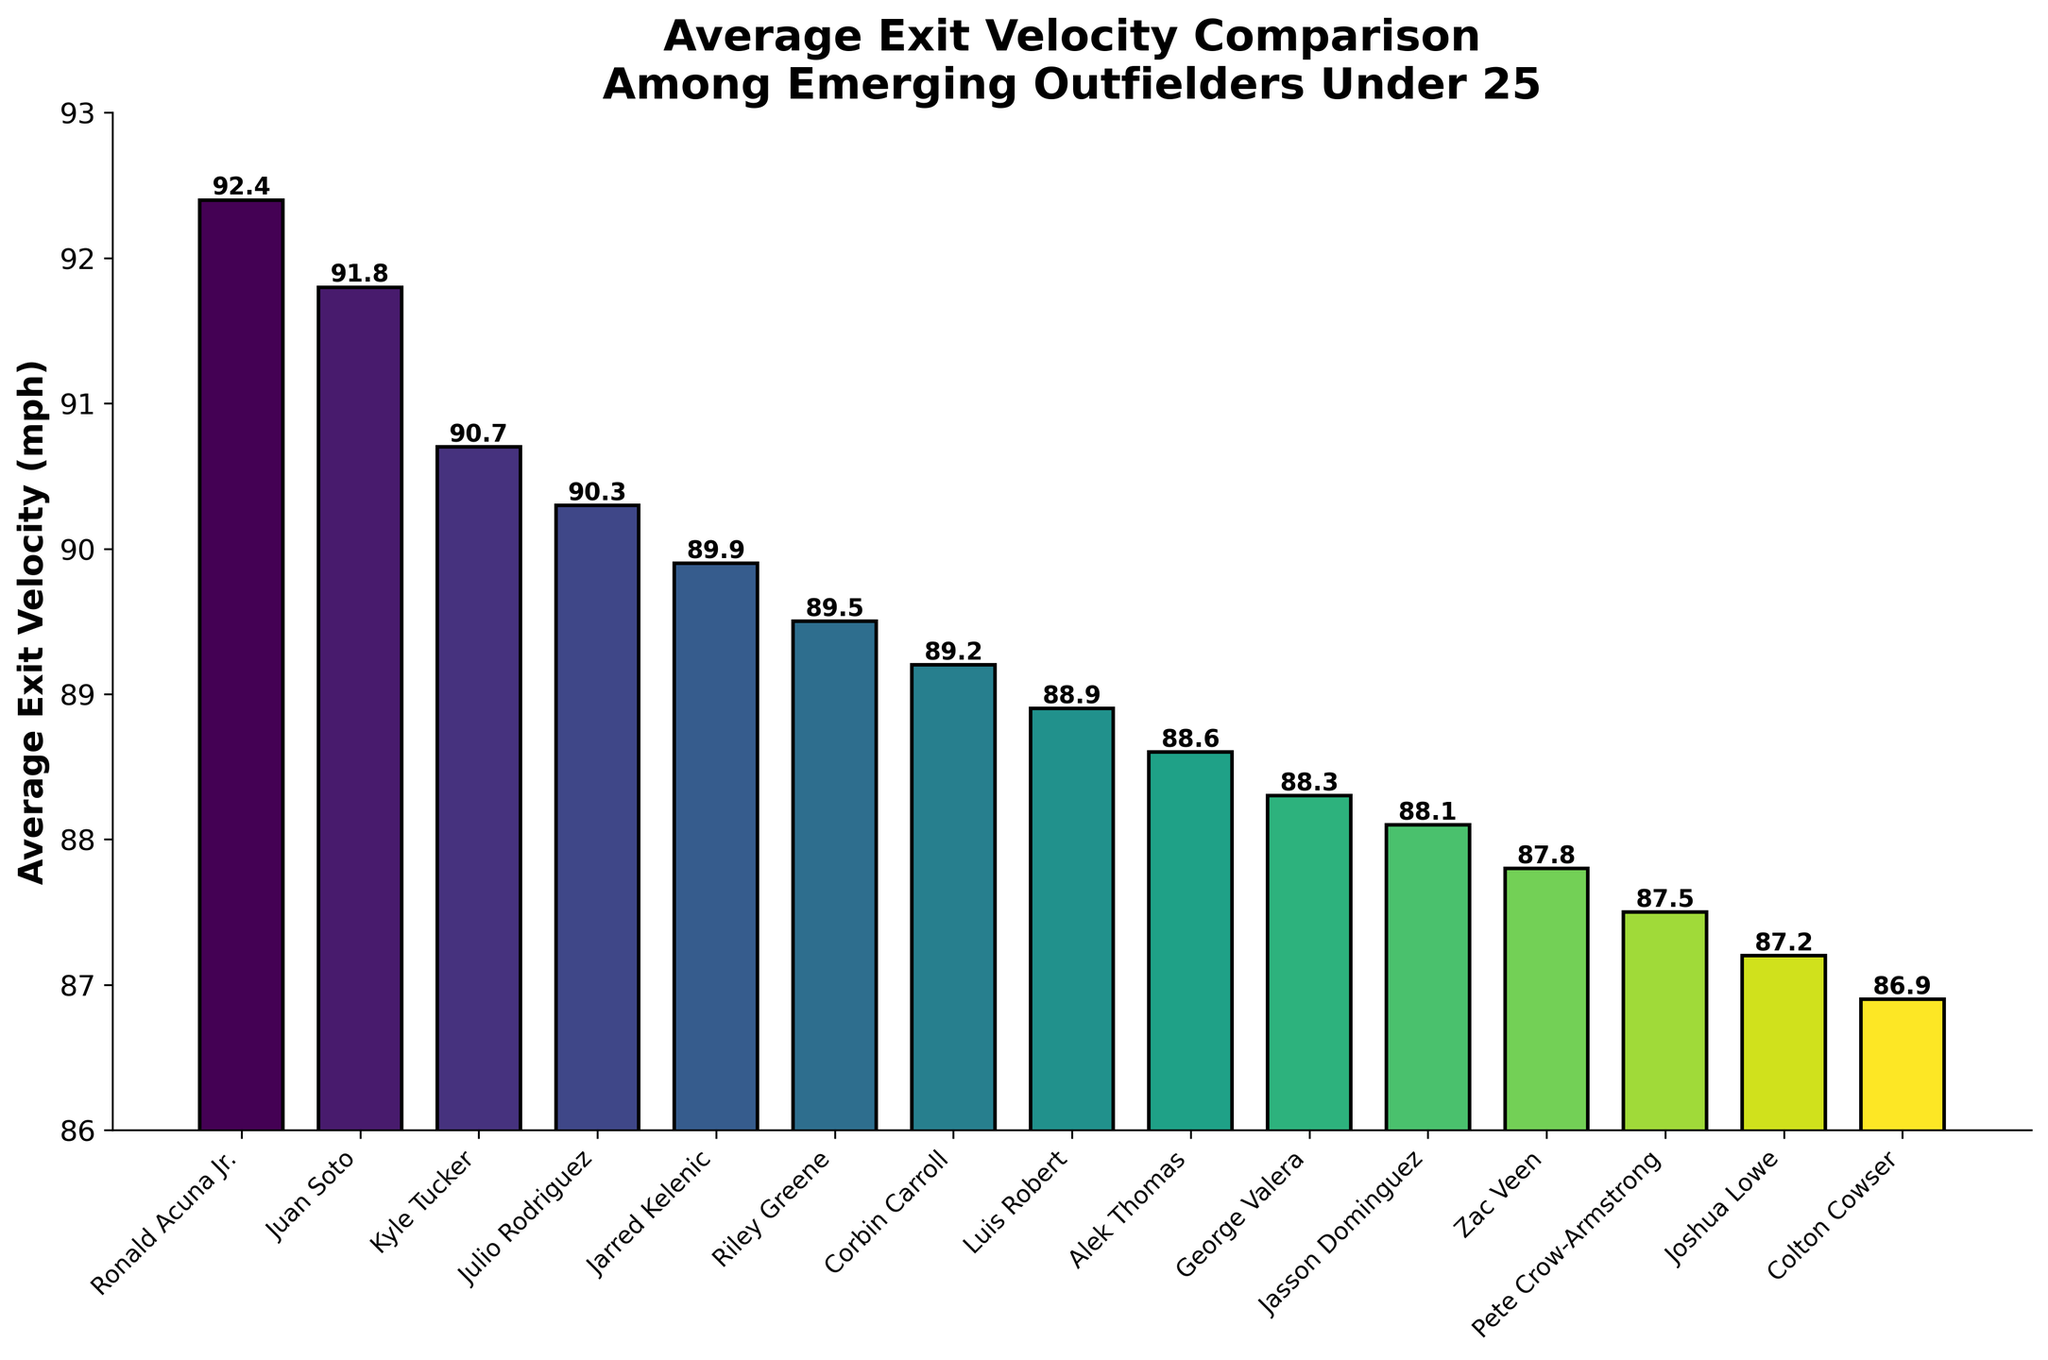What's the player with the highest average exit velocity? The bar representing Ronald Acuna Jr. is the tallest, indicating he has the highest average exit velocity value.
Answer: Ronald Acuna Jr Who has a higher average exit velocity, Ronald Acuna Jr. or Juan Soto? The bar for Ronald Acuna Jr. is taller than that of Juan Soto. Ronald Acuna Jr.'s value is 92.4 mph, and Juan Soto's value is 91.8 mph.
Answer: Ronald Acuna Jr Which players have an average exit velocity less than 90 mph but more than 87 mph? The bars for Jarred Kelenic, Riley Greene, Corbin Carroll, Luis Robert, Alek Thomas, George Valera, Jasson Dominguez, and Zac Veen all fit in this range.
Answer: Jarred Kelenic, Riley Greene, Corbin Carroll, Luis Robert, Alek Thomas, George Valera, Jasson Dominguez, Zac Veen What is the difference in average exit velocity between Kyle Tucker and Julio Rodriguez? Kyle Tucker's bar height represents 90.7 mph, and Julio Rodriguez's bar height represents 90.3 mph. The difference is 90.7 - 90.3.
Answer: 0.4 mph How many players have an average exit velocity of 90 mph or above? By identifying and counting the bars with heights representing 90 mph or higher, we find that there are four such players: Ronald Acuna Jr., Juan Soto, Kyle Tucker, and Julio Rodriguez.
Answer: 4 players What is the average exit velocity of the top three players combined? The top three players are Ronald Acuna Jr., Juan Soto, and Kyle Tucker. Summing their values: 92.4 + 91.8 + 90.7, then dividing by 3, we calculate (92.4 + 91.8 + 90.7) / 3.
Answer: 91.63 mph Which player has the lowest average exit velocity? The shortest bar belongs to Colton Cowser, indicating he has the lowest average exit velocity value.
Answer: Colton Cowser How does Pete Crow-Armstrong's average exit velocity compare to Joshua Lowe's? Pete Crow-Armstrong has an average exit velocity of 87.5 mph, and Joshua Lowe has an average exit velocity of 87.2 mph. Pete Crow-Armstrong's is slightly higher.
Answer: Pete Crow-Armstrong What is the range of average exit velocities among these players? The highest value is Ronald Acuna Jr.'s 92.4 mph and the lowest value is Colton Cowser's 86.9 mph. The range is 92.4 - 86.9.
Answer: 5.5 mph Which player sits right in the middle of the chart in terms of average exit velocity? By counting the total number of players (15) and finding the middle one, the 8th player in descending order of exit velocity is Luis Robert, who is exactly in the middle.
Answer: Luis Robert 